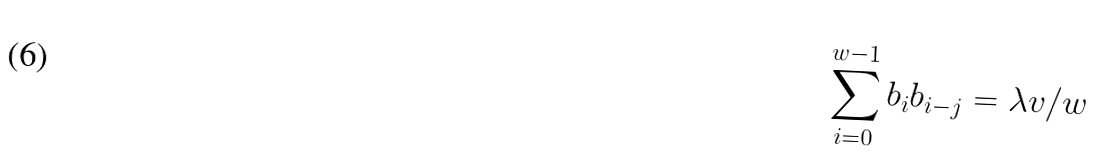Convert formula to latex. <formula><loc_0><loc_0><loc_500><loc_500>\sum _ { i = 0 } ^ { w - 1 } b _ { i } b _ { i - j } = \lambda v / w</formula> 